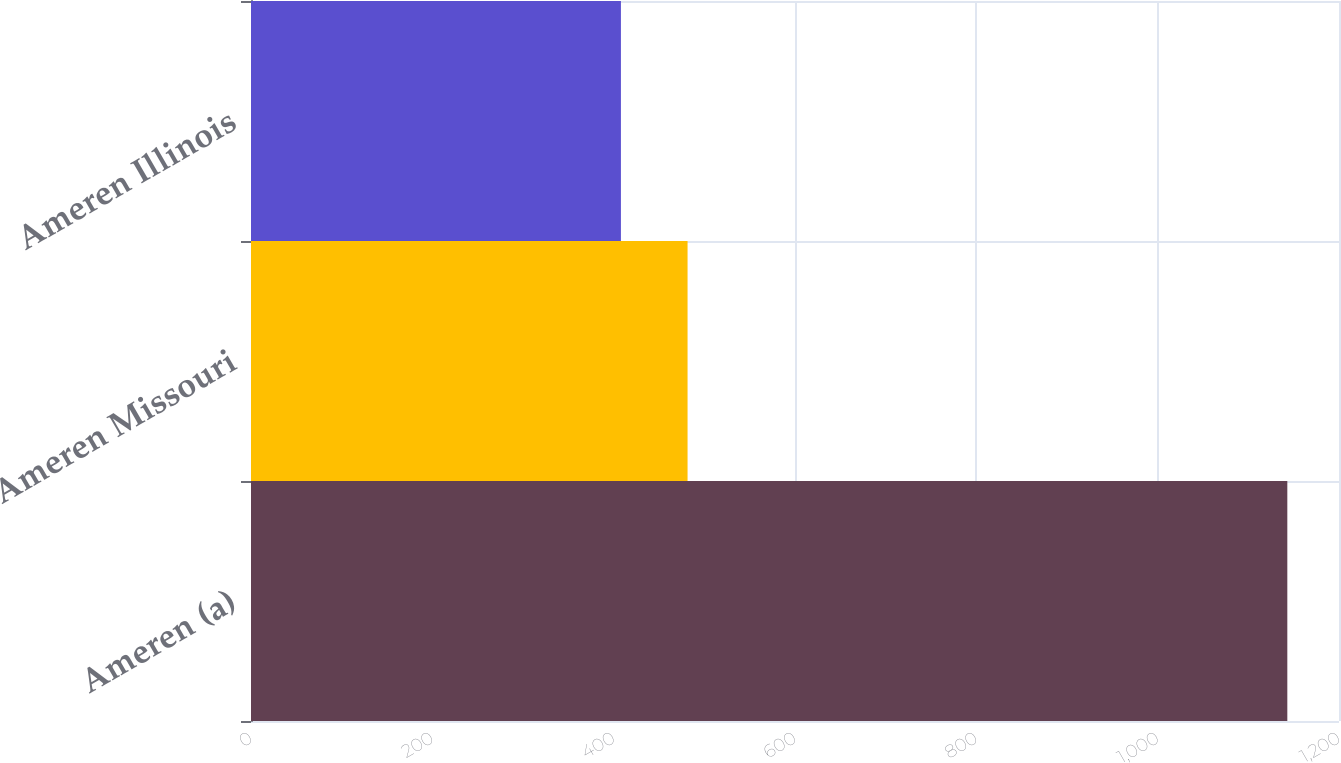Convert chart to OTSL. <chart><loc_0><loc_0><loc_500><loc_500><bar_chart><fcel>Ameren (a)<fcel>Ameren Missouri<fcel>Ameren Illinois<nl><fcel>1143<fcel>481.5<fcel>408<nl></chart> 